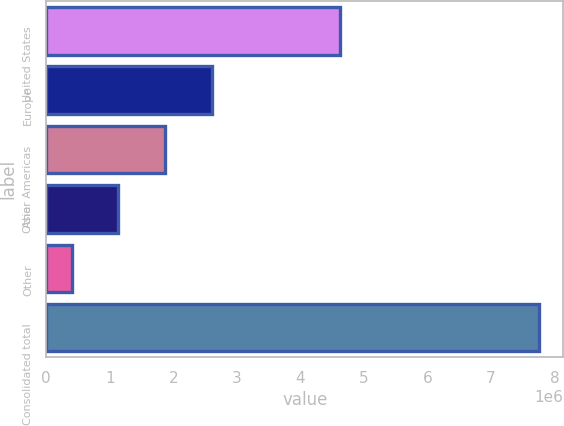<chart> <loc_0><loc_0><loc_500><loc_500><bar_chart><fcel>United States<fcel>Europe<fcel>Other Americas<fcel>Asia<fcel>Other<fcel>Consolidated total<nl><fcel>4.61781e+06<fcel>2.60709e+06<fcel>1.872e+06<fcel>1.1369e+06<fcel>401813<fcel>7.75273e+06<nl></chart> 